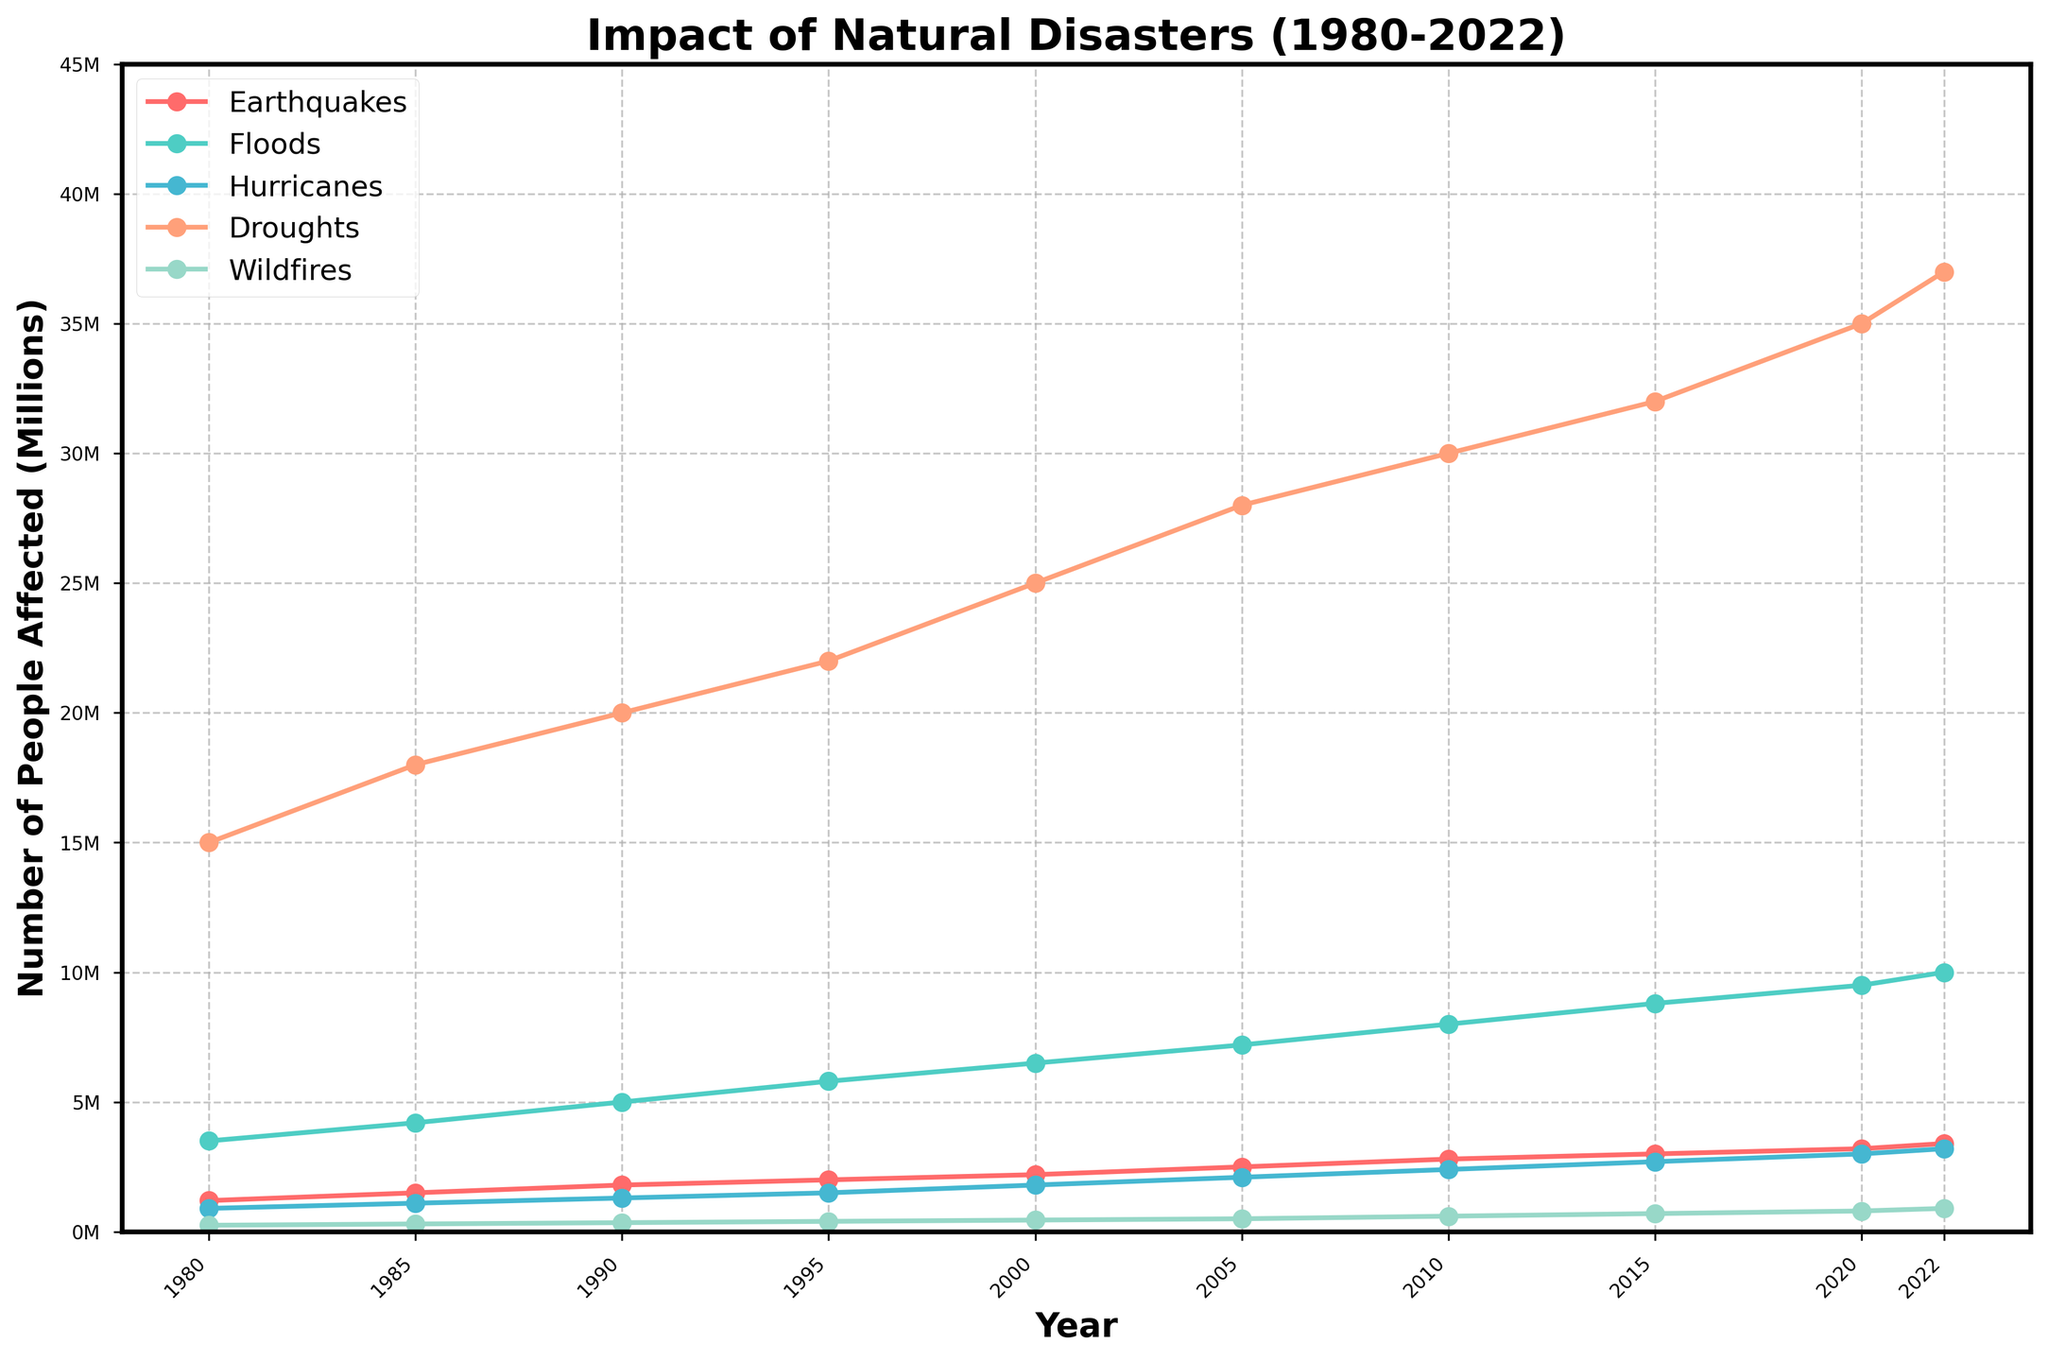Which disaster type affected the highest number of people in 2022? Look at the 2022 data points and compare the values for each disaster type. Droughts affected 37 million people, which is higher than any other disaster type in that year as seen in the plot.
Answer: Droughts How has the number of people affected by floods changed from 1980 to 2022? Check the values for floods in 1980 and 2022. In 1980, 3.5 million people were affected by floods, while in 2022, 10 million people were affected. This indicates an increase over the years.
Answer: Increased Which disaster type shows the least fluctuation over the years? Observe the trends for each disaster type. Wildfires have the least fluctuation, gradually increasing over the years but without significant spikes compared to other disaster types.
Answer: Wildfires In which year did hurricanes affect the most people, and how many were affected? Identify the peak value for hurricanes across the years. In 2022, hurricanes affected the most people with 3.2 million.
Answer: 2022, 3.2 million What is the combined number of people affected by earthquakes and hurricanes in 2022? Find the values for earthquakes and hurricanes in 2022 and sum them up. Earthquakes affected 3.4 million and hurricanes affected 3.2 million. 3.4 million + 3.2 million = 6.6 million.
Answer: 6.6 million Compare the number of people affected by droughts and floods in 2010. Which disaster had a higher impact? Look at the 2010 values for droughts and floods. Droughts affected 30 million people while floods affected 8 million people. Droughts clearly had a higher impact.
Answer: Droughts What is the trend observed in the number of people affected by wildfires from 2000 to 2022? Observe the data points for wildfires from 2000 to 2022. In 2000, 450,000 people were affected, and this number steadily increased to 900,000 by 2022.
Answer: Increasing Calculate the average number of people affected by earthquakes over the decades (i.e., 1980s, 1990s, 2000s, 2010s, 2020s). Sum the number of people affected by earthquakes for each decade and divide by the number of years in that decade. For example, for the 1980s, (1.2M + 1.5M) / 2 = 1.35M; repeat for other decades. Average for 1980s: (1.2M + 1.5M) / 2 = 1.35M; 1990s: (1.8M + 2.0M) / 2 = 1.90M; 2000s: (2.2M + 2.5M) / 2 = 2.35M; 2010s: (2.8M + 3.0M) / 2 = 2.9M; 2020s: (3.2M + 3.4M) / 2 = 3.3M.
Answer: 1980s: 1.35M, 1990s: 1.90M, 2000s: 2.35M, 2010s: 2.9M, 2020s: 3.3M 